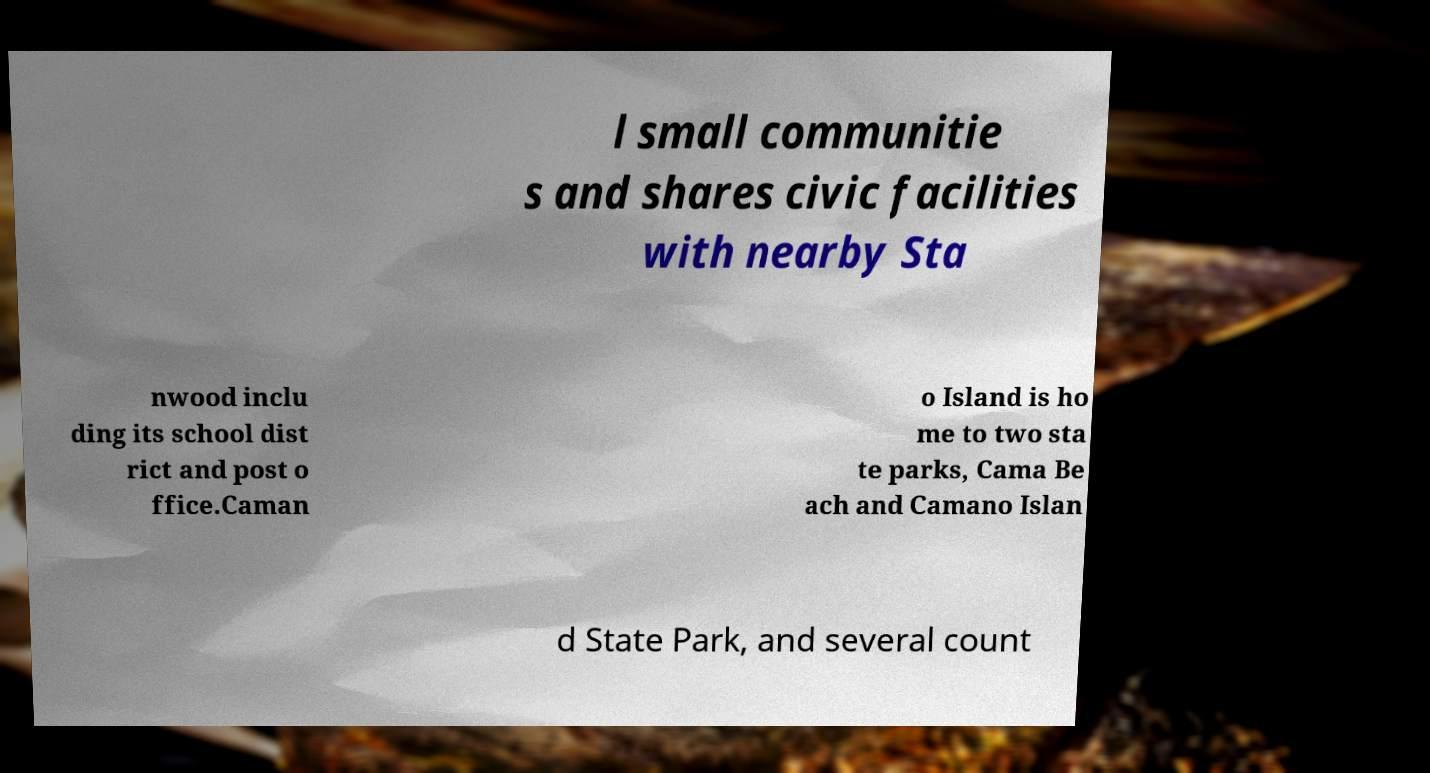Can you read and provide the text displayed in the image?This photo seems to have some interesting text. Can you extract and type it out for me? l small communitie s and shares civic facilities with nearby Sta nwood inclu ding its school dist rict and post o ffice.Caman o Island is ho me to two sta te parks, Cama Be ach and Camano Islan d State Park, and several count 